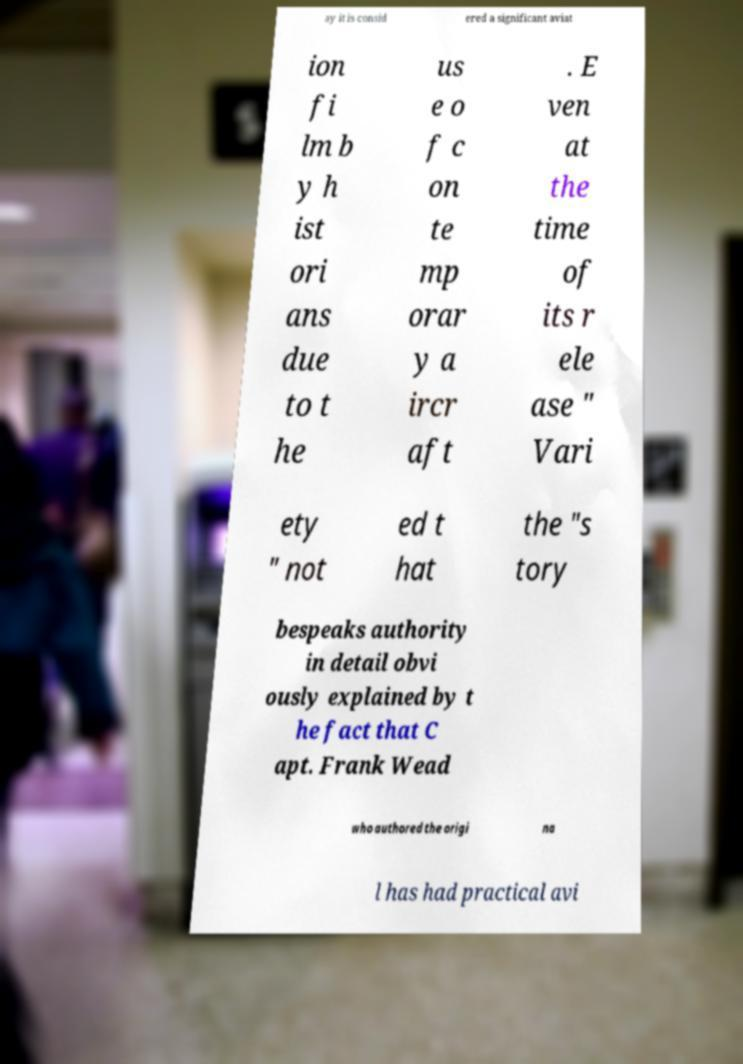I need the written content from this picture converted into text. Can you do that? ay it is consid ered a significant aviat ion fi lm b y h ist ori ans due to t he us e o f c on te mp orar y a ircr aft . E ven at the time of its r ele ase " Vari ety " not ed t hat the "s tory bespeaks authority in detail obvi ously explained by t he fact that C apt. Frank Wead who authored the origi na l has had practical avi 